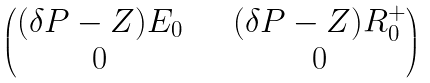<formula> <loc_0><loc_0><loc_500><loc_500>\begin{pmatrix} ( \delta P - Z ) E _ { 0 } & \quad ( \delta P - Z ) R _ { 0 } ^ { + } \\ 0 & \quad 0 \\ \end{pmatrix}</formula> 